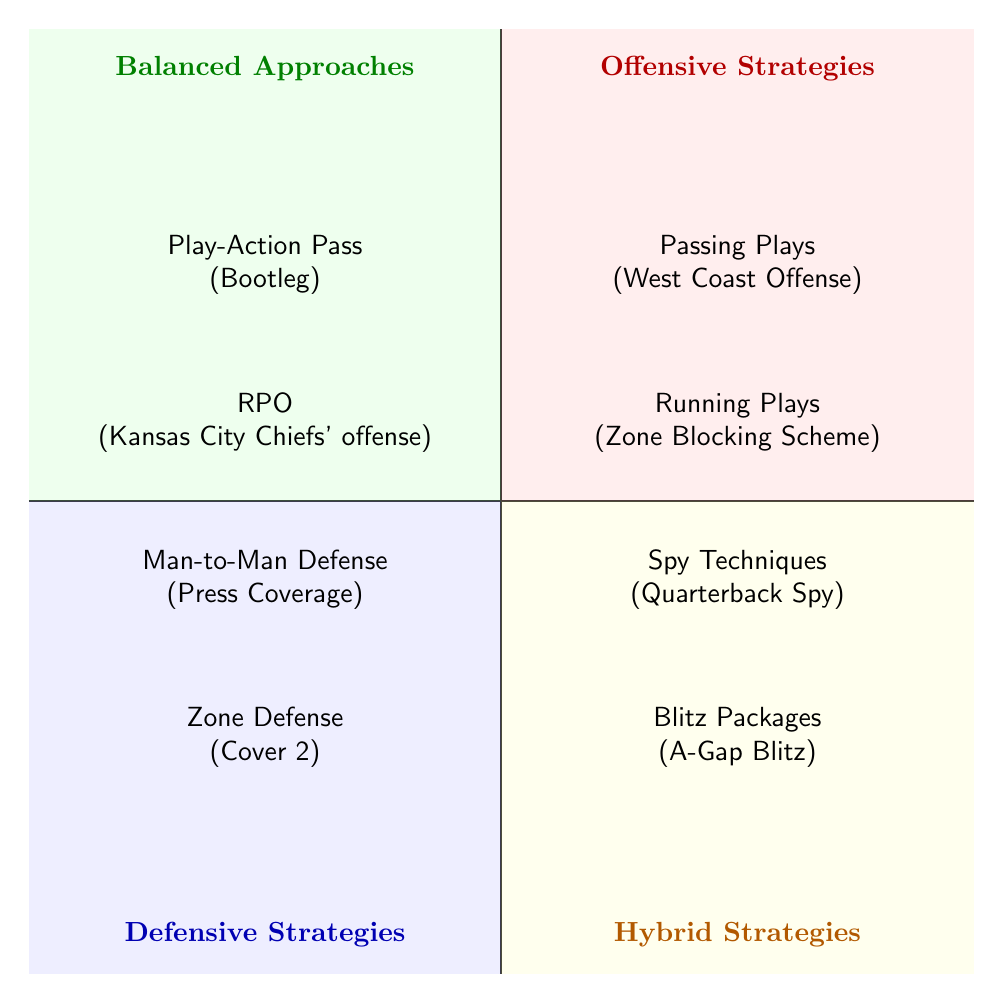What are the two offensive strategies listed? The diagram shows "Passing Plays" and "Running Plays" in the Offensive Strategies quadrant.
Answer: Passing Plays, Running Plays Which defensive strategy is associated with Cover 2? The diagram indicates "Zone Defense" as the strategy associated with Cover 2 in the Defensive Strategies quadrant.
Answer: Zone Defense How many hybrid strategies are mentioned? The Hybrid Strategies quadrant lists two strategies: "Blitz Packages" and "Spy Techniques".
Answer: 2 What type of play is "RPO"? "RPO" represents "Run-Pass Option", as indicated in the Balanced Approaches quadrant of the diagram.
Answer: Run-Pass Option Which quadrant contains the example "A-Gap Blitz"? The "A-Gap Blitz" is represented in the Hybrid Strategies quadrant in the diagram.
Answer: Hybrid Strategies Which quadrant has the least number of strategies listed? After reviewing the quadrants, the Defensive Strategies quadrant has the least number of strategies listed, containing only two strategies.
Answer: Defensive Strategies What is a common example of a passing play? The example given for a passing play is the "West Coast Offense," which is located in the Offensive Strategies quadrant.
Answer: West Coast Offense What strategy is classified as a balanced approach? The "Play-Action Pass" is classified as a balanced approach, as clearly shown in the Balanced Approaches quadrant.
Answer: Play-Action Pass 